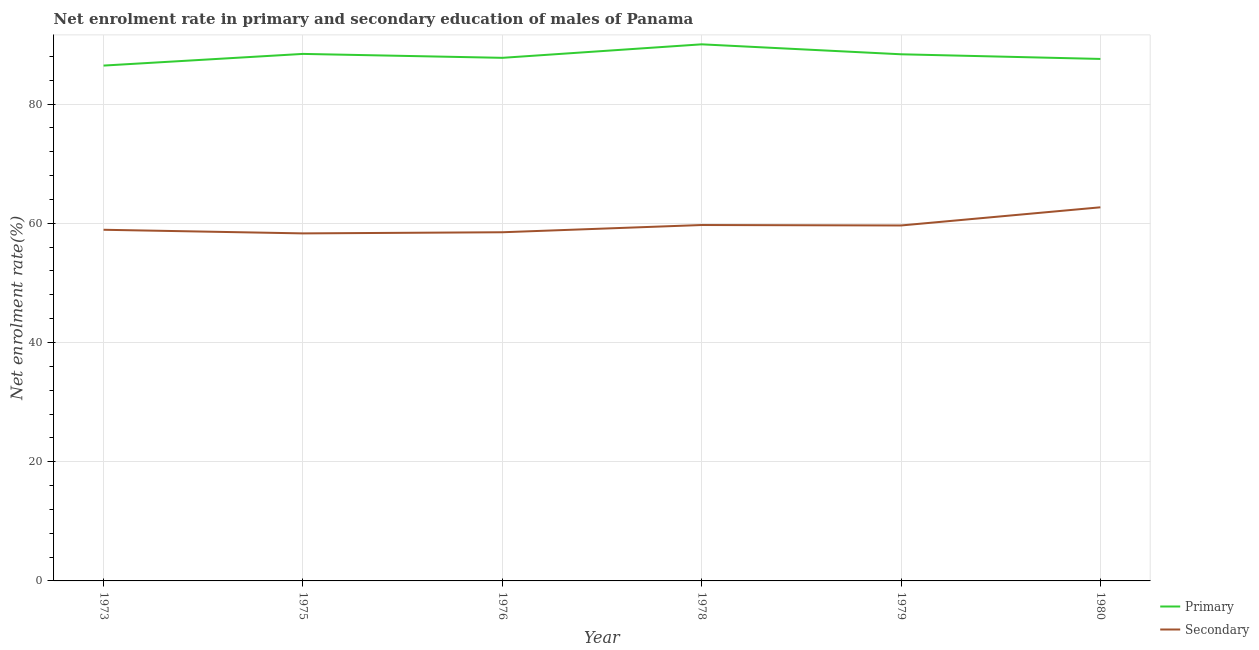How many different coloured lines are there?
Your response must be concise. 2. Does the line corresponding to enrollment rate in secondary education intersect with the line corresponding to enrollment rate in primary education?
Ensure brevity in your answer.  No. What is the enrollment rate in secondary education in 1978?
Ensure brevity in your answer.  59.71. Across all years, what is the maximum enrollment rate in primary education?
Ensure brevity in your answer.  90.02. Across all years, what is the minimum enrollment rate in secondary education?
Offer a very short reply. 58.3. In which year was the enrollment rate in primary education maximum?
Offer a terse response. 1978. What is the total enrollment rate in primary education in the graph?
Offer a very short reply. 528.57. What is the difference between the enrollment rate in primary education in 1975 and that in 1976?
Your response must be concise. 0.66. What is the difference between the enrollment rate in primary education in 1980 and the enrollment rate in secondary education in 1973?
Make the answer very short. 28.66. What is the average enrollment rate in secondary education per year?
Make the answer very short. 59.62. In the year 1979, what is the difference between the enrollment rate in secondary education and enrollment rate in primary education?
Provide a succinct answer. -28.72. What is the ratio of the enrollment rate in primary education in 1979 to that in 1980?
Give a very brief answer. 1.01. What is the difference between the highest and the second highest enrollment rate in primary education?
Provide a succinct answer. 1.61. What is the difference between the highest and the lowest enrollment rate in secondary education?
Provide a succinct answer. 4.38. Does the enrollment rate in secondary education monotonically increase over the years?
Offer a terse response. No. Is the enrollment rate in secondary education strictly greater than the enrollment rate in primary education over the years?
Make the answer very short. No. Is the enrollment rate in secondary education strictly less than the enrollment rate in primary education over the years?
Your answer should be very brief. Yes. How many lines are there?
Ensure brevity in your answer.  2. How many years are there in the graph?
Offer a very short reply. 6. Does the graph contain any zero values?
Give a very brief answer. No. Where does the legend appear in the graph?
Your response must be concise. Bottom right. What is the title of the graph?
Provide a short and direct response. Net enrolment rate in primary and secondary education of males of Panama. Does "Manufacturing industries and construction" appear as one of the legend labels in the graph?
Your response must be concise. No. What is the label or title of the Y-axis?
Make the answer very short. Net enrolment rate(%). What is the Net enrolment rate(%) in Primary in 1973?
Your answer should be compact. 86.46. What is the Net enrolment rate(%) in Secondary in 1973?
Your response must be concise. 58.91. What is the Net enrolment rate(%) of Primary in 1975?
Your response must be concise. 88.41. What is the Net enrolment rate(%) of Secondary in 1975?
Make the answer very short. 58.3. What is the Net enrolment rate(%) in Primary in 1976?
Provide a short and direct response. 87.76. What is the Net enrolment rate(%) of Secondary in 1976?
Ensure brevity in your answer.  58.49. What is the Net enrolment rate(%) in Primary in 1978?
Offer a very short reply. 90.02. What is the Net enrolment rate(%) of Secondary in 1978?
Keep it short and to the point. 59.71. What is the Net enrolment rate(%) in Primary in 1979?
Provide a succinct answer. 88.35. What is the Net enrolment rate(%) of Secondary in 1979?
Give a very brief answer. 59.63. What is the Net enrolment rate(%) of Primary in 1980?
Your answer should be very brief. 87.57. What is the Net enrolment rate(%) of Secondary in 1980?
Your answer should be very brief. 62.68. Across all years, what is the maximum Net enrolment rate(%) of Primary?
Offer a terse response. 90.02. Across all years, what is the maximum Net enrolment rate(%) of Secondary?
Your response must be concise. 62.68. Across all years, what is the minimum Net enrolment rate(%) of Primary?
Provide a short and direct response. 86.46. Across all years, what is the minimum Net enrolment rate(%) in Secondary?
Ensure brevity in your answer.  58.3. What is the total Net enrolment rate(%) in Primary in the graph?
Make the answer very short. 528.57. What is the total Net enrolment rate(%) in Secondary in the graph?
Your response must be concise. 357.73. What is the difference between the Net enrolment rate(%) in Primary in 1973 and that in 1975?
Your response must be concise. -1.96. What is the difference between the Net enrolment rate(%) of Secondary in 1973 and that in 1975?
Give a very brief answer. 0.61. What is the difference between the Net enrolment rate(%) of Primary in 1973 and that in 1976?
Make the answer very short. -1.3. What is the difference between the Net enrolment rate(%) in Secondary in 1973 and that in 1976?
Provide a succinct answer. 0.42. What is the difference between the Net enrolment rate(%) in Primary in 1973 and that in 1978?
Offer a terse response. -3.56. What is the difference between the Net enrolment rate(%) in Secondary in 1973 and that in 1978?
Give a very brief answer. -0.8. What is the difference between the Net enrolment rate(%) of Primary in 1973 and that in 1979?
Make the answer very short. -1.9. What is the difference between the Net enrolment rate(%) of Secondary in 1973 and that in 1979?
Your answer should be compact. -0.72. What is the difference between the Net enrolment rate(%) in Primary in 1973 and that in 1980?
Offer a very short reply. -1.11. What is the difference between the Net enrolment rate(%) in Secondary in 1973 and that in 1980?
Provide a succinct answer. -3.77. What is the difference between the Net enrolment rate(%) of Primary in 1975 and that in 1976?
Your answer should be very brief. 0.66. What is the difference between the Net enrolment rate(%) in Secondary in 1975 and that in 1976?
Your response must be concise. -0.19. What is the difference between the Net enrolment rate(%) of Primary in 1975 and that in 1978?
Your answer should be very brief. -1.61. What is the difference between the Net enrolment rate(%) of Secondary in 1975 and that in 1978?
Your response must be concise. -1.41. What is the difference between the Net enrolment rate(%) in Primary in 1975 and that in 1979?
Provide a short and direct response. 0.06. What is the difference between the Net enrolment rate(%) in Secondary in 1975 and that in 1979?
Keep it short and to the point. -1.33. What is the difference between the Net enrolment rate(%) of Primary in 1975 and that in 1980?
Your response must be concise. 0.84. What is the difference between the Net enrolment rate(%) in Secondary in 1975 and that in 1980?
Offer a terse response. -4.38. What is the difference between the Net enrolment rate(%) of Primary in 1976 and that in 1978?
Provide a succinct answer. -2.27. What is the difference between the Net enrolment rate(%) in Secondary in 1976 and that in 1978?
Offer a terse response. -1.22. What is the difference between the Net enrolment rate(%) in Primary in 1976 and that in 1979?
Give a very brief answer. -0.6. What is the difference between the Net enrolment rate(%) of Secondary in 1976 and that in 1979?
Ensure brevity in your answer.  -1.14. What is the difference between the Net enrolment rate(%) of Primary in 1976 and that in 1980?
Make the answer very short. 0.18. What is the difference between the Net enrolment rate(%) of Secondary in 1976 and that in 1980?
Offer a terse response. -4.19. What is the difference between the Net enrolment rate(%) of Primary in 1978 and that in 1979?
Keep it short and to the point. 1.67. What is the difference between the Net enrolment rate(%) in Secondary in 1978 and that in 1979?
Provide a succinct answer. 0.08. What is the difference between the Net enrolment rate(%) of Primary in 1978 and that in 1980?
Offer a terse response. 2.45. What is the difference between the Net enrolment rate(%) of Secondary in 1978 and that in 1980?
Ensure brevity in your answer.  -2.97. What is the difference between the Net enrolment rate(%) of Primary in 1979 and that in 1980?
Give a very brief answer. 0.78. What is the difference between the Net enrolment rate(%) in Secondary in 1979 and that in 1980?
Offer a very short reply. -3.05. What is the difference between the Net enrolment rate(%) in Primary in 1973 and the Net enrolment rate(%) in Secondary in 1975?
Offer a very short reply. 28.15. What is the difference between the Net enrolment rate(%) of Primary in 1973 and the Net enrolment rate(%) of Secondary in 1976?
Make the answer very short. 27.96. What is the difference between the Net enrolment rate(%) in Primary in 1973 and the Net enrolment rate(%) in Secondary in 1978?
Your response must be concise. 26.75. What is the difference between the Net enrolment rate(%) of Primary in 1973 and the Net enrolment rate(%) of Secondary in 1979?
Give a very brief answer. 26.82. What is the difference between the Net enrolment rate(%) in Primary in 1973 and the Net enrolment rate(%) in Secondary in 1980?
Give a very brief answer. 23.78. What is the difference between the Net enrolment rate(%) in Primary in 1975 and the Net enrolment rate(%) in Secondary in 1976?
Your answer should be compact. 29.92. What is the difference between the Net enrolment rate(%) of Primary in 1975 and the Net enrolment rate(%) of Secondary in 1978?
Keep it short and to the point. 28.71. What is the difference between the Net enrolment rate(%) in Primary in 1975 and the Net enrolment rate(%) in Secondary in 1979?
Ensure brevity in your answer.  28.78. What is the difference between the Net enrolment rate(%) of Primary in 1975 and the Net enrolment rate(%) of Secondary in 1980?
Keep it short and to the point. 25.73. What is the difference between the Net enrolment rate(%) of Primary in 1976 and the Net enrolment rate(%) of Secondary in 1978?
Provide a succinct answer. 28.05. What is the difference between the Net enrolment rate(%) of Primary in 1976 and the Net enrolment rate(%) of Secondary in 1979?
Keep it short and to the point. 28.12. What is the difference between the Net enrolment rate(%) in Primary in 1976 and the Net enrolment rate(%) in Secondary in 1980?
Offer a very short reply. 25.08. What is the difference between the Net enrolment rate(%) of Primary in 1978 and the Net enrolment rate(%) of Secondary in 1979?
Offer a very short reply. 30.39. What is the difference between the Net enrolment rate(%) in Primary in 1978 and the Net enrolment rate(%) in Secondary in 1980?
Offer a very short reply. 27.34. What is the difference between the Net enrolment rate(%) of Primary in 1979 and the Net enrolment rate(%) of Secondary in 1980?
Ensure brevity in your answer.  25.67. What is the average Net enrolment rate(%) in Primary per year?
Give a very brief answer. 88.1. What is the average Net enrolment rate(%) of Secondary per year?
Give a very brief answer. 59.62. In the year 1973, what is the difference between the Net enrolment rate(%) of Primary and Net enrolment rate(%) of Secondary?
Provide a short and direct response. 27.55. In the year 1975, what is the difference between the Net enrolment rate(%) of Primary and Net enrolment rate(%) of Secondary?
Make the answer very short. 30.11. In the year 1976, what is the difference between the Net enrolment rate(%) of Primary and Net enrolment rate(%) of Secondary?
Provide a succinct answer. 29.26. In the year 1978, what is the difference between the Net enrolment rate(%) in Primary and Net enrolment rate(%) in Secondary?
Your response must be concise. 30.31. In the year 1979, what is the difference between the Net enrolment rate(%) of Primary and Net enrolment rate(%) of Secondary?
Your answer should be compact. 28.72. In the year 1980, what is the difference between the Net enrolment rate(%) in Primary and Net enrolment rate(%) in Secondary?
Give a very brief answer. 24.89. What is the ratio of the Net enrolment rate(%) of Primary in 1973 to that in 1975?
Provide a succinct answer. 0.98. What is the ratio of the Net enrolment rate(%) of Secondary in 1973 to that in 1975?
Provide a succinct answer. 1.01. What is the ratio of the Net enrolment rate(%) in Primary in 1973 to that in 1976?
Make the answer very short. 0.99. What is the ratio of the Net enrolment rate(%) of Secondary in 1973 to that in 1976?
Offer a terse response. 1.01. What is the ratio of the Net enrolment rate(%) of Primary in 1973 to that in 1978?
Your answer should be very brief. 0.96. What is the ratio of the Net enrolment rate(%) in Secondary in 1973 to that in 1978?
Your response must be concise. 0.99. What is the ratio of the Net enrolment rate(%) in Primary in 1973 to that in 1979?
Your response must be concise. 0.98. What is the ratio of the Net enrolment rate(%) in Secondary in 1973 to that in 1979?
Make the answer very short. 0.99. What is the ratio of the Net enrolment rate(%) of Primary in 1973 to that in 1980?
Your answer should be compact. 0.99. What is the ratio of the Net enrolment rate(%) in Secondary in 1973 to that in 1980?
Provide a short and direct response. 0.94. What is the ratio of the Net enrolment rate(%) of Primary in 1975 to that in 1976?
Give a very brief answer. 1.01. What is the ratio of the Net enrolment rate(%) of Primary in 1975 to that in 1978?
Provide a succinct answer. 0.98. What is the ratio of the Net enrolment rate(%) in Secondary in 1975 to that in 1978?
Offer a very short reply. 0.98. What is the ratio of the Net enrolment rate(%) of Primary in 1975 to that in 1979?
Offer a terse response. 1. What is the ratio of the Net enrolment rate(%) in Secondary in 1975 to that in 1979?
Offer a very short reply. 0.98. What is the ratio of the Net enrolment rate(%) in Primary in 1975 to that in 1980?
Your answer should be very brief. 1.01. What is the ratio of the Net enrolment rate(%) in Secondary in 1975 to that in 1980?
Make the answer very short. 0.93. What is the ratio of the Net enrolment rate(%) in Primary in 1976 to that in 1978?
Offer a very short reply. 0.97. What is the ratio of the Net enrolment rate(%) in Secondary in 1976 to that in 1978?
Offer a very short reply. 0.98. What is the ratio of the Net enrolment rate(%) in Secondary in 1976 to that in 1979?
Provide a succinct answer. 0.98. What is the ratio of the Net enrolment rate(%) of Primary in 1976 to that in 1980?
Ensure brevity in your answer.  1. What is the ratio of the Net enrolment rate(%) in Secondary in 1976 to that in 1980?
Your answer should be very brief. 0.93. What is the ratio of the Net enrolment rate(%) of Primary in 1978 to that in 1979?
Offer a very short reply. 1.02. What is the ratio of the Net enrolment rate(%) of Secondary in 1978 to that in 1979?
Provide a succinct answer. 1. What is the ratio of the Net enrolment rate(%) in Primary in 1978 to that in 1980?
Give a very brief answer. 1.03. What is the ratio of the Net enrolment rate(%) of Secondary in 1978 to that in 1980?
Ensure brevity in your answer.  0.95. What is the ratio of the Net enrolment rate(%) in Primary in 1979 to that in 1980?
Provide a succinct answer. 1.01. What is the ratio of the Net enrolment rate(%) in Secondary in 1979 to that in 1980?
Your answer should be very brief. 0.95. What is the difference between the highest and the second highest Net enrolment rate(%) of Primary?
Make the answer very short. 1.61. What is the difference between the highest and the second highest Net enrolment rate(%) in Secondary?
Give a very brief answer. 2.97. What is the difference between the highest and the lowest Net enrolment rate(%) in Primary?
Your answer should be compact. 3.56. What is the difference between the highest and the lowest Net enrolment rate(%) of Secondary?
Offer a very short reply. 4.38. 